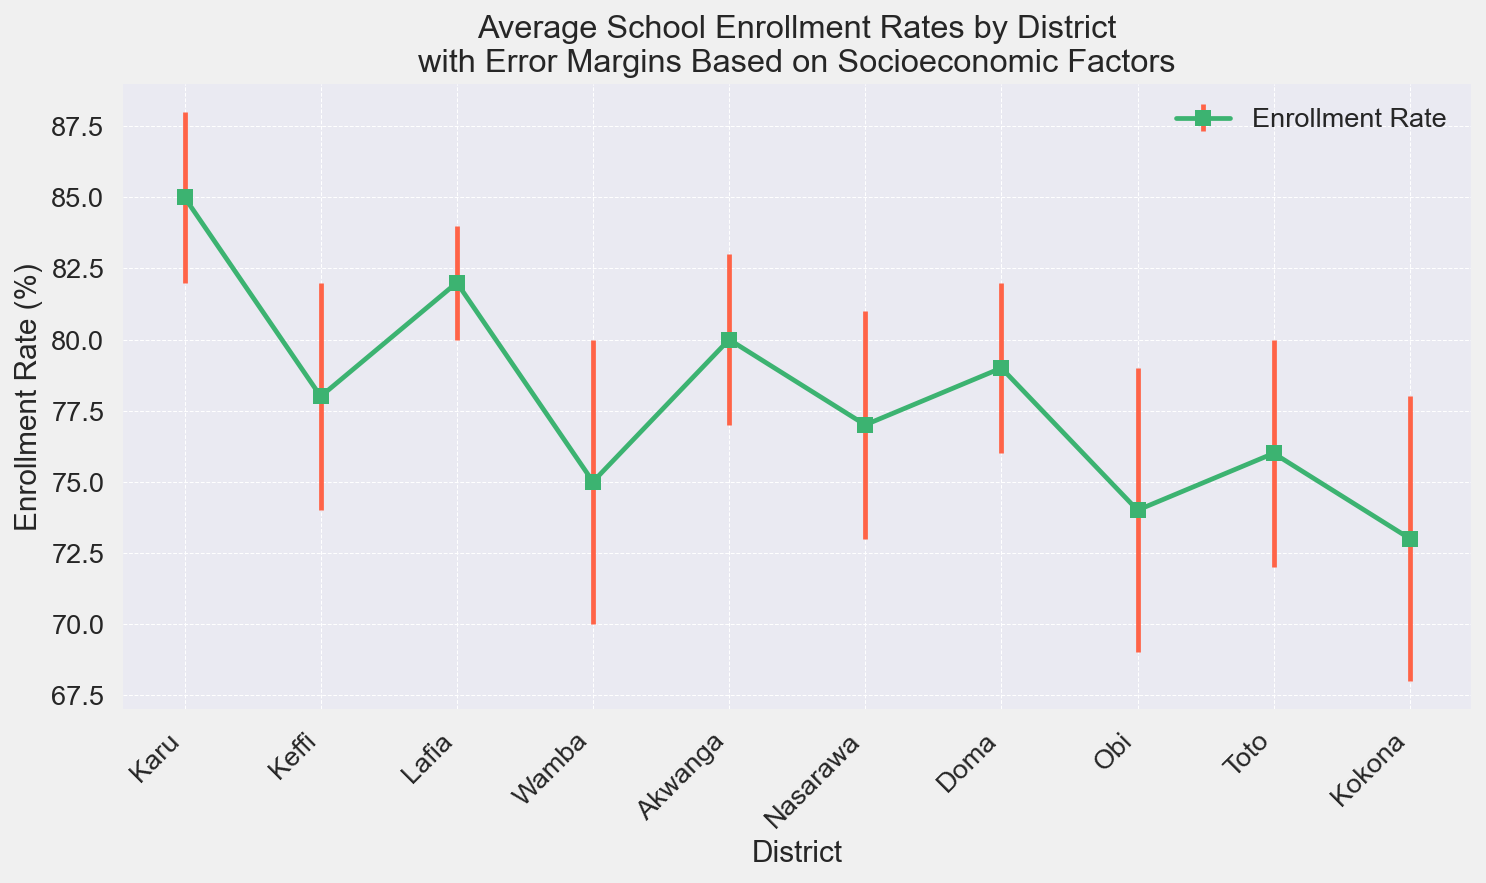Which district has the highest enrollment rate? Observe the vertical height of the markers. The district with the tallest marker represents the highest enrollment rate.
Answer: Karu Which district has the lowest enrollment rate? Look for the shortest marker in the chart. This represents the lowest enrollment rate.
Answer: Kokona What is the difference in enrollment rates between Karu and Kokona? Karu's enrollment rate is 85, and Kokona's enrollment rate is 73. Subtract Kokona's rate from Karu's rate: 85 - 73 = 12.
Answer: 12 Which districts have an enrollment rate greater than 80%? Identify the markers that are above the 80% line. Then, list the corresponding districts.
Answer: Karu, Lafia, Akwanga What is the median enrollment rate of all districts represented? The enrollment rates are: 85, 78, 82, 75, 80, 77, 79, 74, 76, 73. Sort and find the middle value or the average of the two middle values (80 + 77)/2 = 78.5.
Answer: 78.5 Which district has the largest error margin? Identify the district with the widest error bars. Refer to the "Error Margin" value in the chart.
Answer: Wamba, Obi, Kokona What is the total error margin combined for Keffi and Nasarawa? Sum the error margins for Keffi (4) and Nasarawa (4): 4 + 4 = 8.
Answer: 8 Which districts have an enrollment rate within 2% of the median enrollment rate? The median enrollment rate is 78.5. Look for districts with rates between 76.5 and 80.5.
Answer: Keffi, Akwanga, Nasarawa, Doma How does the enrollment rate of Doma compare to that of Keffi? Observe the markers for Doma and Keffi. Doma's rate (79) is higher than Keffi's rate (78).
Answer: Doma has a higher enrollment rate What is the average error margin across all districts? Sum all error margins and divide by the number of districts: (3+4+2+5+3+4+3+5+4+5)/10 = 38/10 = 3.8.
Answer: 3.8 